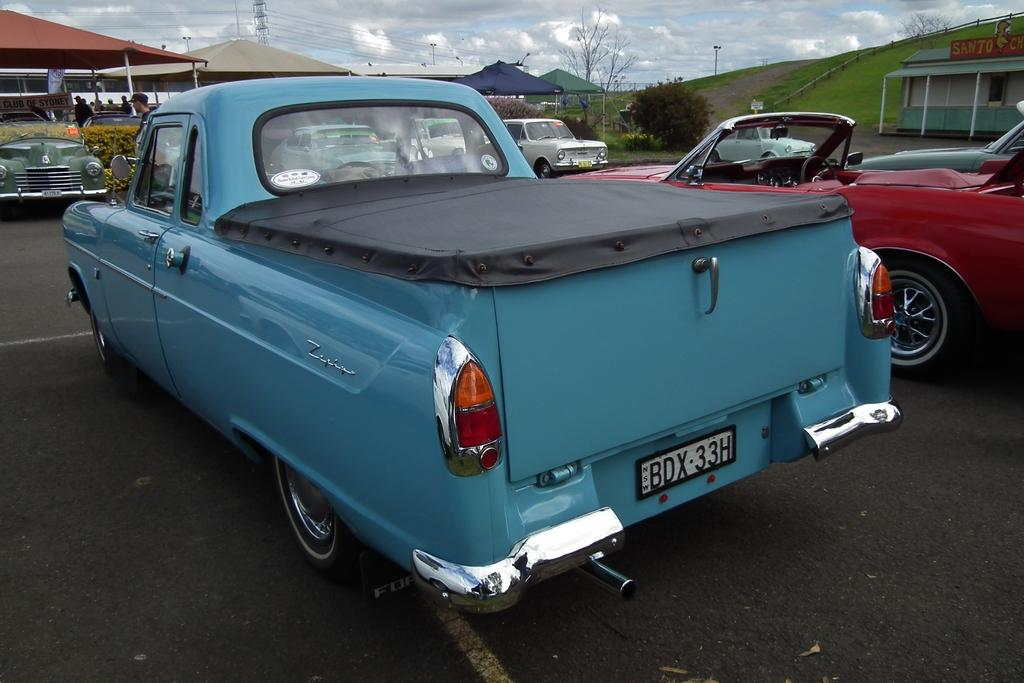What type of vehicles are parked in the image? There are cars parked in the image. What type of temporary shelters can be seen in the image? There are tents in the image. Can you describe the people in the image? There are people in the image. What type of vegetation is present in the image? There are trees in the image. What type of man-made structure can be seen in the image? There is a building in the image. What type of linear object can be seen in the image? There is a wire in the image. What type of vertical object can be seen in the image? There is a pole in the image. Can you tell me how many squirrels are sitting on the wire in the image? There are no squirrels present in the image. What type of riddle can be solved by looking at the image? There is no riddle present in the image, and therefore no such activity can be observed. 